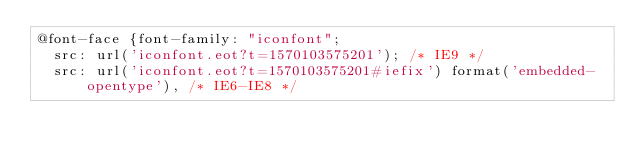Convert code to text. <code><loc_0><loc_0><loc_500><loc_500><_CSS_>@font-face {font-family: "iconfont";
  src: url('iconfont.eot?t=1570103575201'); /* IE9 */
  src: url('iconfont.eot?t=1570103575201#iefix') format('embedded-opentype'), /* IE6-IE8 */</code> 